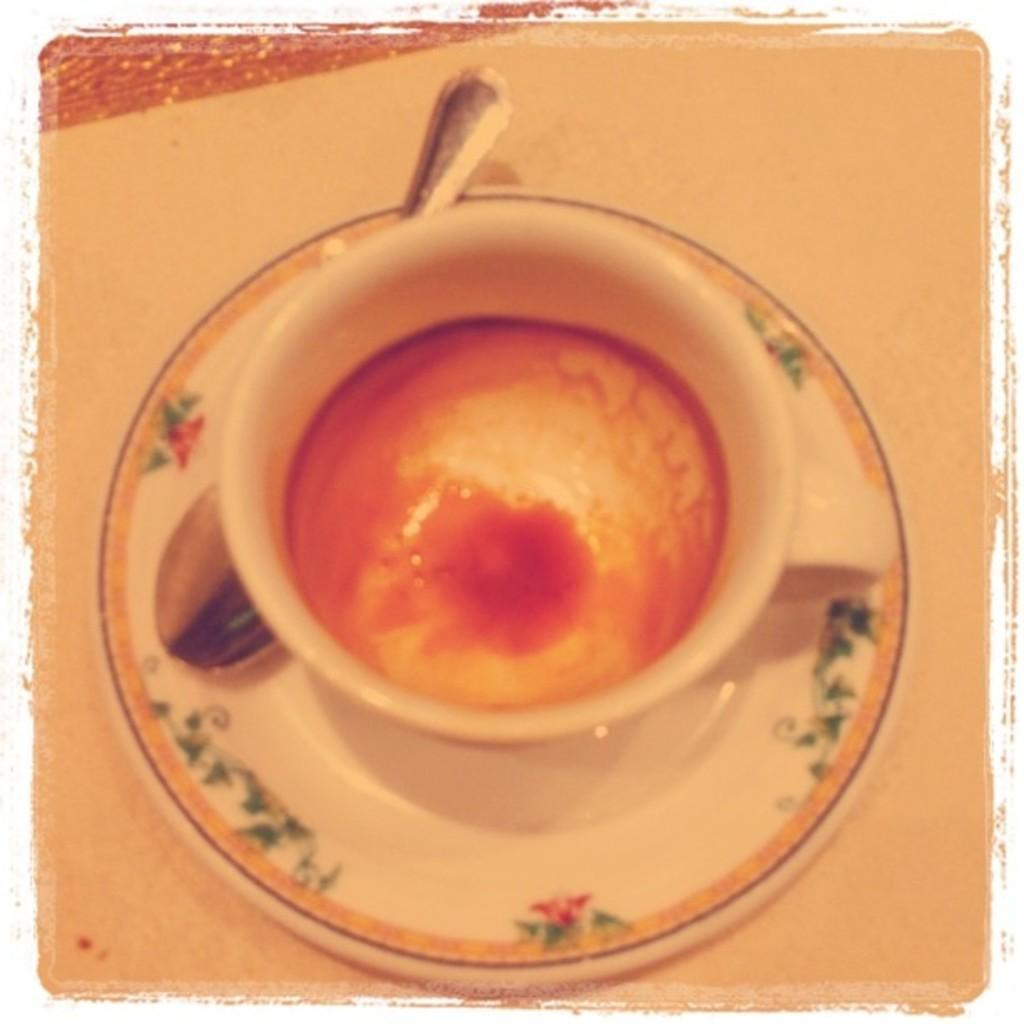What is the main object in the image? There is a saucer in the image. What is located beneath the saucer? There is an object beneath the saucer. What is placed on top of the saucer? There is a spoon on the saucer. What is on the saucer along with the spoon? There is a cup with liquid on the saucer. What type of furniture is depicted in the image? There is no furniture present in the image. How much rice is visible in the image? There is no rice present in the image. 